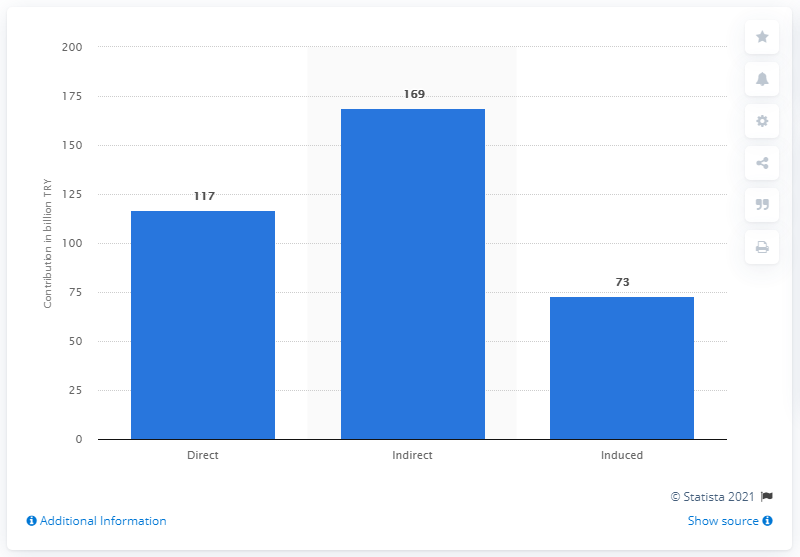Specify some key components in this picture. In 2017, the travel and tourism sector contributed a total of 117 Turkish lira to the Turkish economy. 